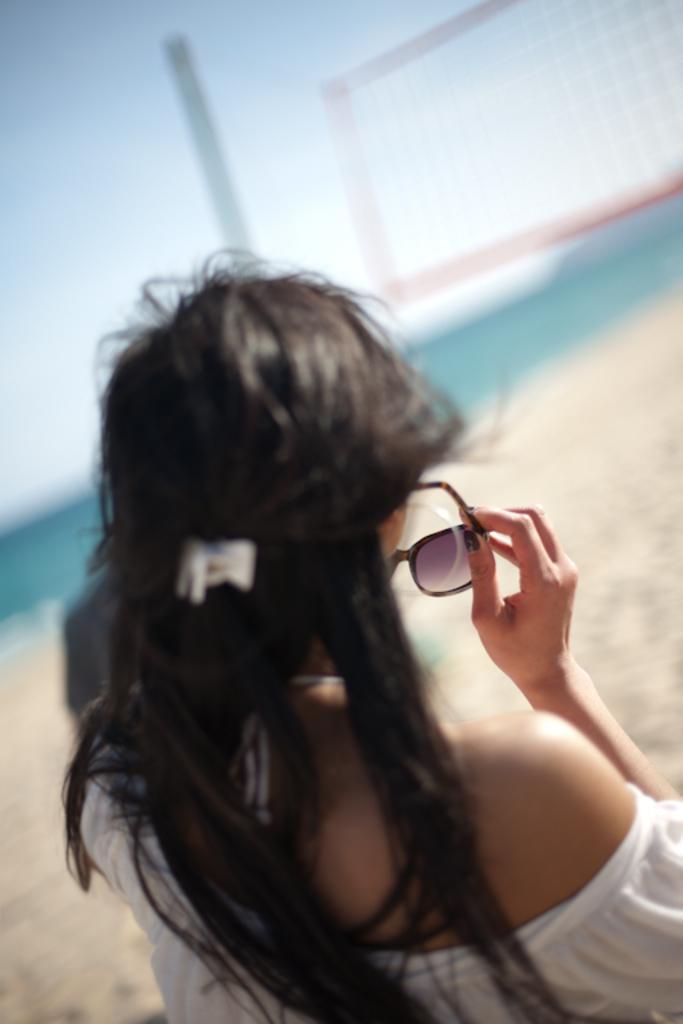Describe this image in one or two sentences. In this image there is a person holding spectacles, and there is blur background. 